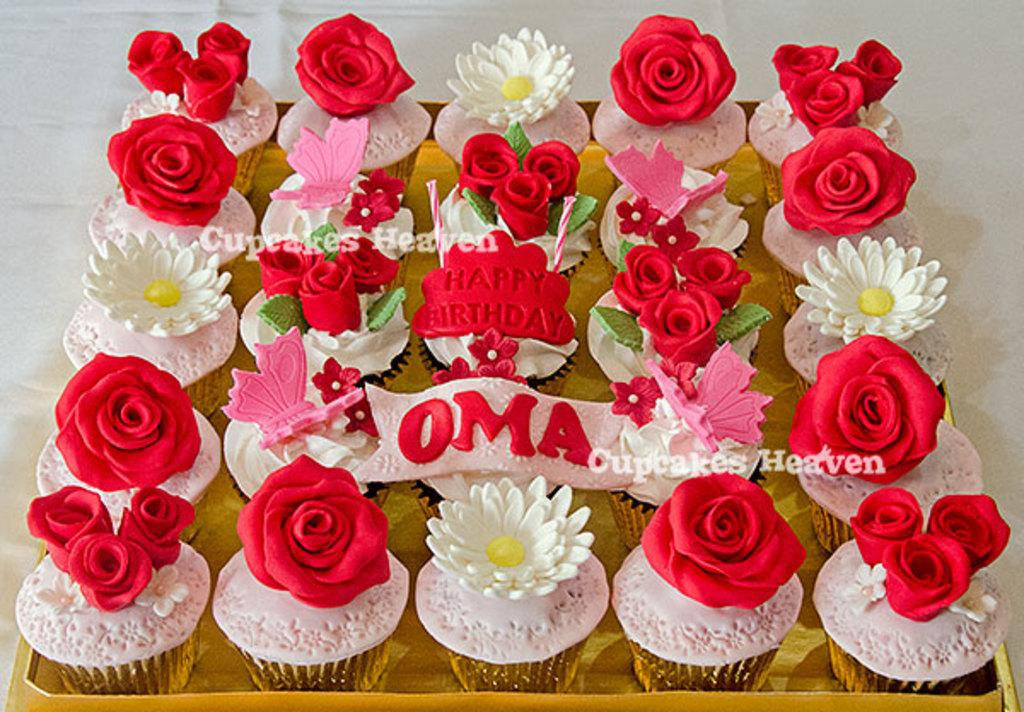What type of objects are present in the image? There are flower-shaped objects in the image. What colors are the flowers? The flowers are white and red in color. Is there any text or writing in the image? Yes, there is something written in the image. Can you describe any other features of the image? There are watermarks on the image. Are there any gloves visible in the image? No, there are no gloves present in the image. Can you tell me how many people are swimming in the image? There is no swimming or people depicted in the image; it features flower-shaped objects, writing, and watermarks. 